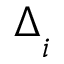Convert formula to latex. <formula><loc_0><loc_0><loc_500><loc_500>\Delta _ { _ { i } }</formula> 